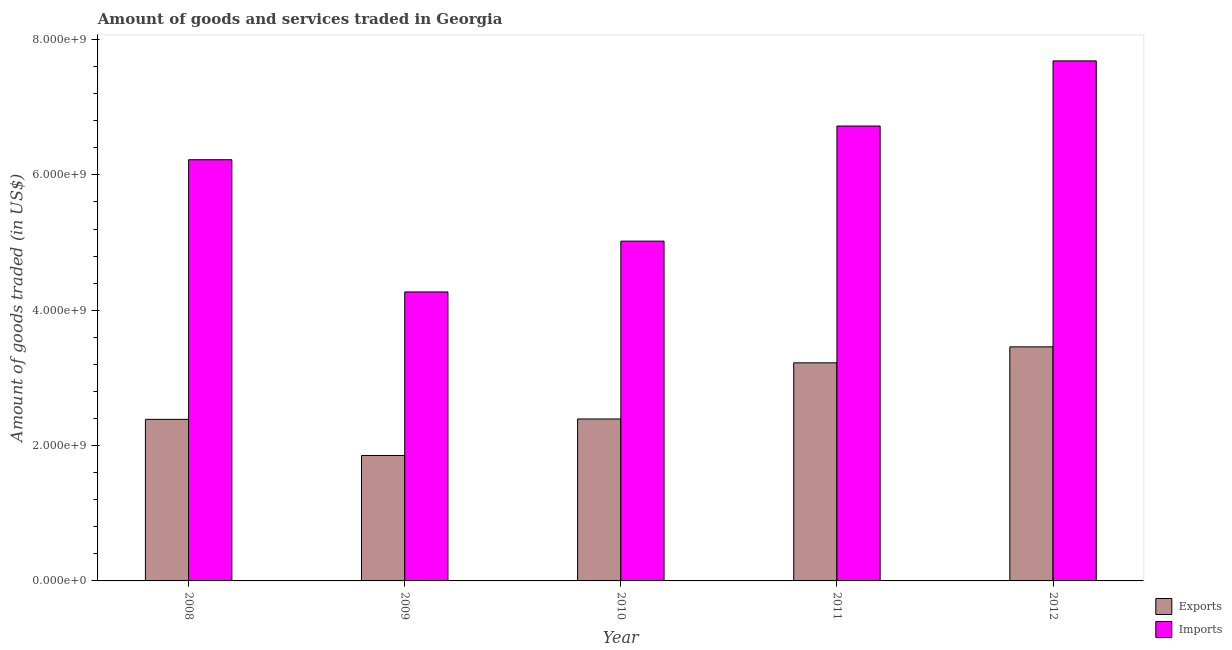Are the number of bars per tick equal to the number of legend labels?
Keep it short and to the point. Yes. How many bars are there on the 5th tick from the right?
Your response must be concise. 2. What is the amount of goods exported in 2011?
Ensure brevity in your answer.  3.22e+09. Across all years, what is the maximum amount of goods exported?
Give a very brief answer. 3.46e+09. Across all years, what is the minimum amount of goods exported?
Give a very brief answer. 1.85e+09. In which year was the amount of goods exported maximum?
Provide a short and direct response. 2012. In which year was the amount of goods imported minimum?
Your answer should be compact. 2009. What is the total amount of goods exported in the graph?
Offer a terse response. 1.33e+1. What is the difference between the amount of goods exported in 2009 and that in 2012?
Offer a terse response. -1.61e+09. What is the difference between the amount of goods imported in 2012 and the amount of goods exported in 2008?
Provide a succinct answer. 1.46e+09. What is the average amount of goods exported per year?
Keep it short and to the point. 2.66e+09. What is the ratio of the amount of goods exported in 2009 to that in 2011?
Make the answer very short. 0.58. Is the amount of goods exported in 2009 less than that in 2010?
Provide a succinct answer. Yes. Is the difference between the amount of goods imported in 2009 and 2010 greater than the difference between the amount of goods exported in 2009 and 2010?
Provide a short and direct response. No. What is the difference between the highest and the second highest amount of goods imported?
Ensure brevity in your answer.  9.63e+08. What is the difference between the highest and the lowest amount of goods imported?
Give a very brief answer. 3.41e+09. In how many years, is the amount of goods exported greater than the average amount of goods exported taken over all years?
Your answer should be compact. 2. Is the sum of the amount of goods imported in 2009 and 2010 greater than the maximum amount of goods exported across all years?
Provide a short and direct response. Yes. What does the 2nd bar from the left in 2011 represents?
Offer a very short reply. Imports. What does the 1st bar from the right in 2012 represents?
Ensure brevity in your answer.  Imports. How many bars are there?
Provide a succinct answer. 10. Are all the bars in the graph horizontal?
Offer a terse response. No. What is the difference between two consecutive major ticks on the Y-axis?
Ensure brevity in your answer.  2.00e+09. Are the values on the major ticks of Y-axis written in scientific E-notation?
Offer a terse response. Yes. Does the graph contain grids?
Provide a short and direct response. No. Where does the legend appear in the graph?
Offer a terse response. Bottom right. How many legend labels are there?
Give a very brief answer. 2. How are the legend labels stacked?
Make the answer very short. Vertical. What is the title of the graph?
Make the answer very short. Amount of goods and services traded in Georgia. What is the label or title of the X-axis?
Keep it short and to the point. Year. What is the label or title of the Y-axis?
Your answer should be very brief. Amount of goods traded (in US$). What is the Amount of goods traded (in US$) of Exports in 2008?
Provide a short and direct response. 2.39e+09. What is the Amount of goods traded (in US$) in Imports in 2008?
Your response must be concise. 6.22e+09. What is the Amount of goods traded (in US$) of Exports in 2009?
Make the answer very short. 1.85e+09. What is the Amount of goods traded (in US$) of Imports in 2009?
Make the answer very short. 4.27e+09. What is the Amount of goods traded (in US$) of Exports in 2010?
Provide a succinct answer. 2.39e+09. What is the Amount of goods traded (in US$) of Imports in 2010?
Your response must be concise. 5.02e+09. What is the Amount of goods traded (in US$) in Exports in 2011?
Your response must be concise. 3.22e+09. What is the Amount of goods traded (in US$) of Imports in 2011?
Keep it short and to the point. 6.72e+09. What is the Amount of goods traded (in US$) in Exports in 2012?
Your answer should be compact. 3.46e+09. What is the Amount of goods traded (in US$) in Imports in 2012?
Ensure brevity in your answer.  7.69e+09. Across all years, what is the maximum Amount of goods traded (in US$) of Exports?
Provide a succinct answer. 3.46e+09. Across all years, what is the maximum Amount of goods traded (in US$) of Imports?
Offer a very short reply. 7.69e+09. Across all years, what is the minimum Amount of goods traded (in US$) in Exports?
Make the answer very short. 1.85e+09. Across all years, what is the minimum Amount of goods traded (in US$) of Imports?
Give a very brief answer. 4.27e+09. What is the total Amount of goods traded (in US$) of Exports in the graph?
Offer a terse response. 1.33e+1. What is the total Amount of goods traded (in US$) of Imports in the graph?
Offer a very short reply. 2.99e+1. What is the difference between the Amount of goods traded (in US$) in Exports in 2008 and that in 2009?
Your response must be concise. 5.34e+08. What is the difference between the Amount of goods traded (in US$) of Imports in 2008 and that in 2009?
Provide a short and direct response. 1.95e+09. What is the difference between the Amount of goods traded (in US$) in Exports in 2008 and that in 2010?
Make the answer very short. -5.67e+06. What is the difference between the Amount of goods traded (in US$) of Imports in 2008 and that in 2010?
Give a very brief answer. 1.20e+09. What is the difference between the Amount of goods traded (in US$) in Exports in 2008 and that in 2011?
Keep it short and to the point. -8.35e+08. What is the difference between the Amount of goods traded (in US$) of Imports in 2008 and that in 2011?
Your answer should be compact. -4.98e+08. What is the difference between the Amount of goods traded (in US$) of Exports in 2008 and that in 2012?
Make the answer very short. -1.07e+09. What is the difference between the Amount of goods traded (in US$) in Imports in 2008 and that in 2012?
Provide a succinct answer. -1.46e+09. What is the difference between the Amount of goods traded (in US$) of Exports in 2009 and that in 2010?
Offer a very short reply. -5.40e+08. What is the difference between the Amount of goods traded (in US$) in Imports in 2009 and that in 2010?
Offer a very short reply. -7.51e+08. What is the difference between the Amount of goods traded (in US$) in Exports in 2009 and that in 2011?
Give a very brief answer. -1.37e+09. What is the difference between the Amount of goods traded (in US$) in Imports in 2009 and that in 2011?
Make the answer very short. -2.45e+09. What is the difference between the Amount of goods traded (in US$) of Exports in 2009 and that in 2012?
Offer a very short reply. -1.61e+09. What is the difference between the Amount of goods traded (in US$) in Imports in 2009 and that in 2012?
Provide a succinct answer. -3.41e+09. What is the difference between the Amount of goods traded (in US$) in Exports in 2010 and that in 2011?
Offer a very short reply. -8.30e+08. What is the difference between the Amount of goods traded (in US$) in Imports in 2010 and that in 2011?
Offer a very short reply. -1.70e+09. What is the difference between the Amount of goods traded (in US$) in Exports in 2010 and that in 2012?
Keep it short and to the point. -1.07e+09. What is the difference between the Amount of goods traded (in US$) of Imports in 2010 and that in 2012?
Your answer should be compact. -2.66e+09. What is the difference between the Amount of goods traded (in US$) of Exports in 2011 and that in 2012?
Ensure brevity in your answer.  -2.36e+08. What is the difference between the Amount of goods traded (in US$) in Imports in 2011 and that in 2012?
Your response must be concise. -9.63e+08. What is the difference between the Amount of goods traded (in US$) in Exports in 2008 and the Amount of goods traded (in US$) in Imports in 2009?
Provide a succinct answer. -1.88e+09. What is the difference between the Amount of goods traded (in US$) in Exports in 2008 and the Amount of goods traded (in US$) in Imports in 2010?
Your response must be concise. -2.63e+09. What is the difference between the Amount of goods traded (in US$) of Exports in 2008 and the Amount of goods traded (in US$) of Imports in 2011?
Offer a very short reply. -4.33e+09. What is the difference between the Amount of goods traded (in US$) of Exports in 2008 and the Amount of goods traded (in US$) of Imports in 2012?
Give a very brief answer. -5.30e+09. What is the difference between the Amount of goods traded (in US$) in Exports in 2009 and the Amount of goods traded (in US$) in Imports in 2010?
Offer a very short reply. -3.17e+09. What is the difference between the Amount of goods traded (in US$) of Exports in 2009 and the Amount of goods traded (in US$) of Imports in 2011?
Your answer should be very brief. -4.87e+09. What is the difference between the Amount of goods traded (in US$) in Exports in 2009 and the Amount of goods traded (in US$) in Imports in 2012?
Ensure brevity in your answer.  -5.83e+09. What is the difference between the Amount of goods traded (in US$) of Exports in 2010 and the Amount of goods traded (in US$) of Imports in 2011?
Provide a succinct answer. -4.33e+09. What is the difference between the Amount of goods traded (in US$) in Exports in 2010 and the Amount of goods traded (in US$) in Imports in 2012?
Provide a succinct answer. -5.29e+09. What is the difference between the Amount of goods traded (in US$) of Exports in 2011 and the Amount of goods traded (in US$) of Imports in 2012?
Make the answer very short. -4.46e+09. What is the average Amount of goods traded (in US$) in Exports per year?
Provide a short and direct response. 2.66e+09. What is the average Amount of goods traded (in US$) of Imports per year?
Offer a terse response. 5.98e+09. In the year 2008, what is the difference between the Amount of goods traded (in US$) of Exports and Amount of goods traded (in US$) of Imports?
Make the answer very short. -3.84e+09. In the year 2009, what is the difference between the Amount of goods traded (in US$) in Exports and Amount of goods traded (in US$) in Imports?
Give a very brief answer. -2.42e+09. In the year 2010, what is the difference between the Amount of goods traded (in US$) of Exports and Amount of goods traded (in US$) of Imports?
Make the answer very short. -2.63e+09. In the year 2011, what is the difference between the Amount of goods traded (in US$) in Exports and Amount of goods traded (in US$) in Imports?
Your response must be concise. -3.50e+09. In the year 2012, what is the difference between the Amount of goods traded (in US$) in Exports and Amount of goods traded (in US$) in Imports?
Provide a short and direct response. -4.23e+09. What is the ratio of the Amount of goods traded (in US$) in Exports in 2008 to that in 2009?
Ensure brevity in your answer.  1.29. What is the ratio of the Amount of goods traded (in US$) of Imports in 2008 to that in 2009?
Provide a succinct answer. 1.46. What is the ratio of the Amount of goods traded (in US$) of Exports in 2008 to that in 2010?
Your answer should be compact. 1. What is the ratio of the Amount of goods traded (in US$) of Imports in 2008 to that in 2010?
Offer a very short reply. 1.24. What is the ratio of the Amount of goods traded (in US$) of Exports in 2008 to that in 2011?
Offer a very short reply. 0.74. What is the ratio of the Amount of goods traded (in US$) of Imports in 2008 to that in 2011?
Offer a terse response. 0.93. What is the ratio of the Amount of goods traded (in US$) of Exports in 2008 to that in 2012?
Make the answer very short. 0.69. What is the ratio of the Amount of goods traded (in US$) in Imports in 2008 to that in 2012?
Offer a very short reply. 0.81. What is the ratio of the Amount of goods traded (in US$) in Exports in 2009 to that in 2010?
Offer a very short reply. 0.77. What is the ratio of the Amount of goods traded (in US$) of Imports in 2009 to that in 2010?
Provide a short and direct response. 0.85. What is the ratio of the Amount of goods traded (in US$) in Exports in 2009 to that in 2011?
Ensure brevity in your answer.  0.58. What is the ratio of the Amount of goods traded (in US$) in Imports in 2009 to that in 2011?
Your response must be concise. 0.64. What is the ratio of the Amount of goods traded (in US$) of Exports in 2009 to that in 2012?
Make the answer very short. 0.54. What is the ratio of the Amount of goods traded (in US$) in Imports in 2009 to that in 2012?
Offer a very short reply. 0.56. What is the ratio of the Amount of goods traded (in US$) of Exports in 2010 to that in 2011?
Keep it short and to the point. 0.74. What is the ratio of the Amount of goods traded (in US$) in Imports in 2010 to that in 2011?
Give a very brief answer. 0.75. What is the ratio of the Amount of goods traded (in US$) of Exports in 2010 to that in 2012?
Keep it short and to the point. 0.69. What is the ratio of the Amount of goods traded (in US$) of Imports in 2010 to that in 2012?
Provide a short and direct response. 0.65. What is the ratio of the Amount of goods traded (in US$) in Exports in 2011 to that in 2012?
Offer a very short reply. 0.93. What is the ratio of the Amount of goods traded (in US$) in Imports in 2011 to that in 2012?
Give a very brief answer. 0.87. What is the difference between the highest and the second highest Amount of goods traded (in US$) in Exports?
Your answer should be very brief. 2.36e+08. What is the difference between the highest and the second highest Amount of goods traded (in US$) in Imports?
Ensure brevity in your answer.  9.63e+08. What is the difference between the highest and the lowest Amount of goods traded (in US$) of Exports?
Offer a terse response. 1.61e+09. What is the difference between the highest and the lowest Amount of goods traded (in US$) of Imports?
Your answer should be compact. 3.41e+09. 